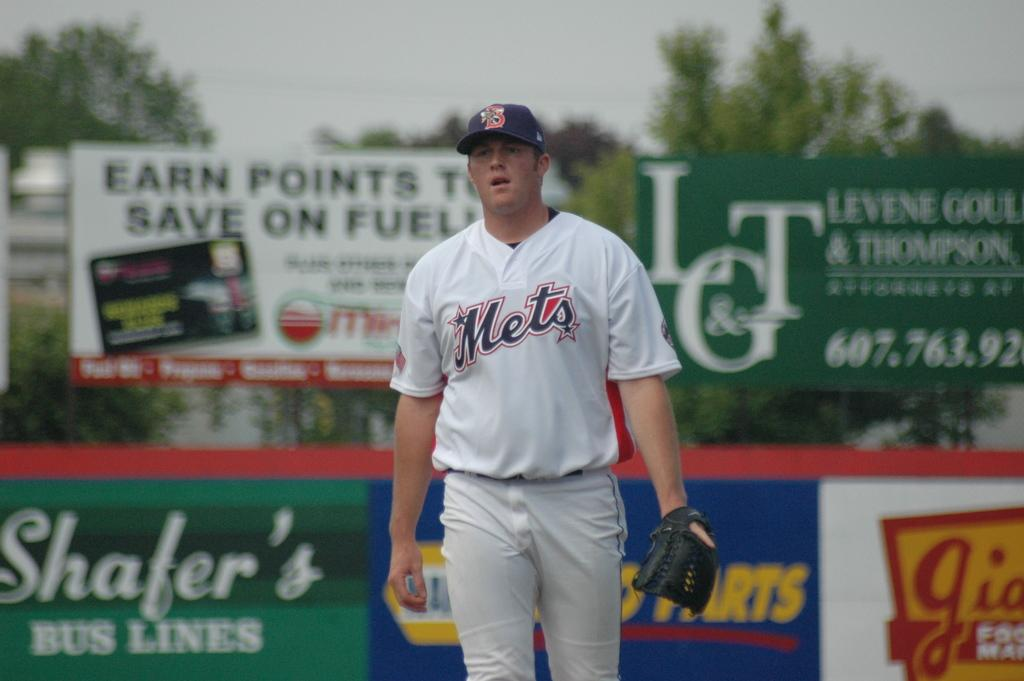<image>
Give a short and clear explanation of the subsequent image. A man in a Mets shirt and cap standing and looking. 